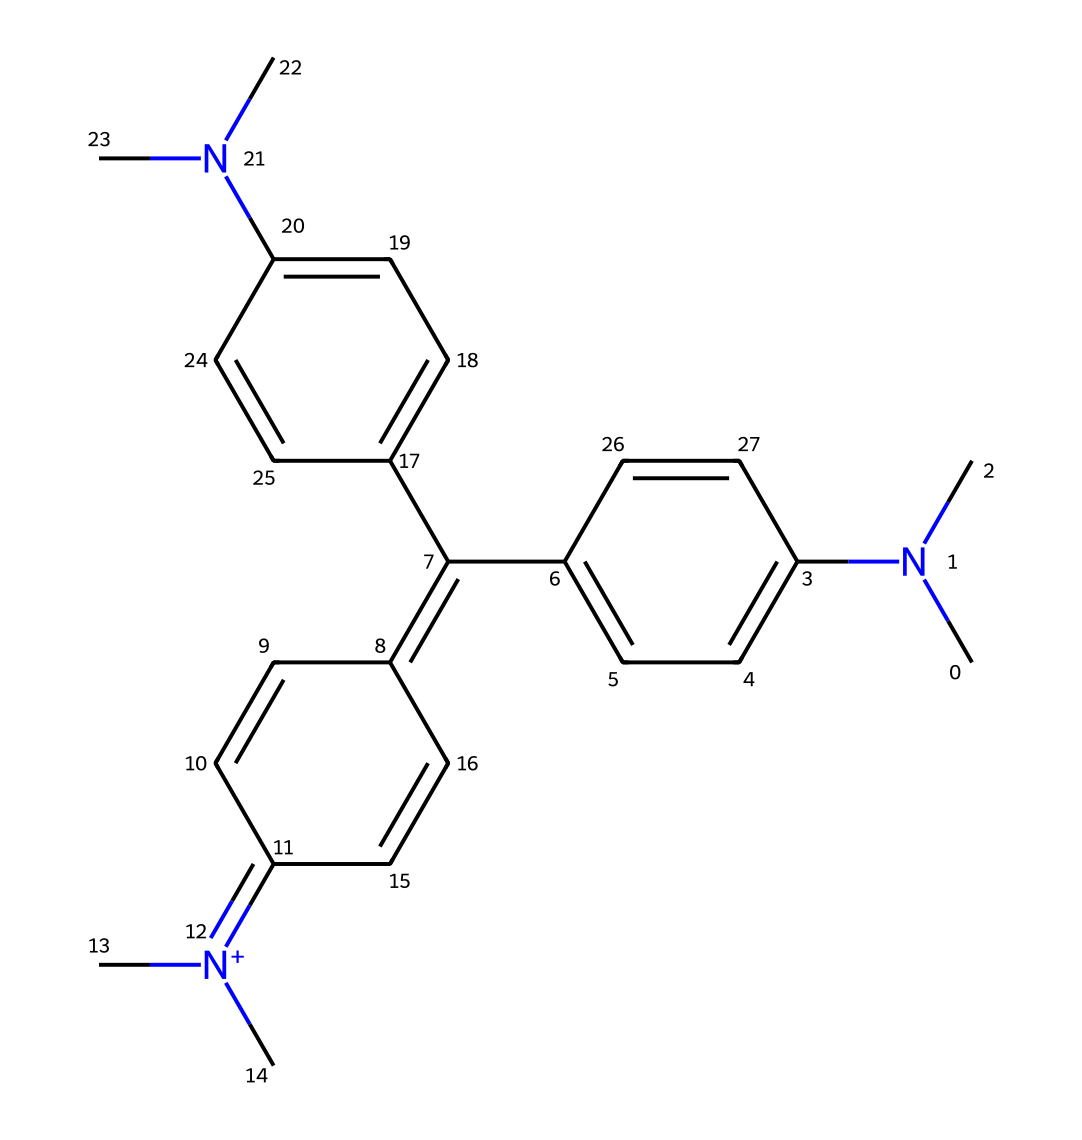What is the total number of carbon atoms in this molecule? By counting the carbon atoms represented in the structure, I identify that there are a total of 25 carbon atoms.
Answer: 25 How many nitrogen atoms are present in this ink molecule? The structure contains two nitrogen atoms, both of which are involved in contributing to the dye properties of the ink.
Answer: 2 Is the molecule predominantly aromatic or aliphatic? The presence of multiple aromatic rings (identified by alternating double bonds) indicates that the molecule is predominantly aromatic.
Answer: aromatic What functional groups are present in this chemical structure? The structure showcases amine groups (due to the nitrogen atoms) and a quaternary ammonium group (indicated by the positively charged nitrogen), characteristic of dye molecules.
Answer: amine, quaternary ammonium What color is likely associated with this dye based on its structure? The presence of multiple conjugated double bonds suggests that this dye would absorb light effectively, likely resulting in a vibrant color, typically seen in many azo or anthraquinone dyes.
Answer: vibrant color What role do the methyl groups play in this dye? The methyl groups, indicated by the "C" attached to nitrogen atoms, influence the solubility and stability of the dye while also potentially affecting the final color due to electronic effects.
Answer: influence solubility and stability 